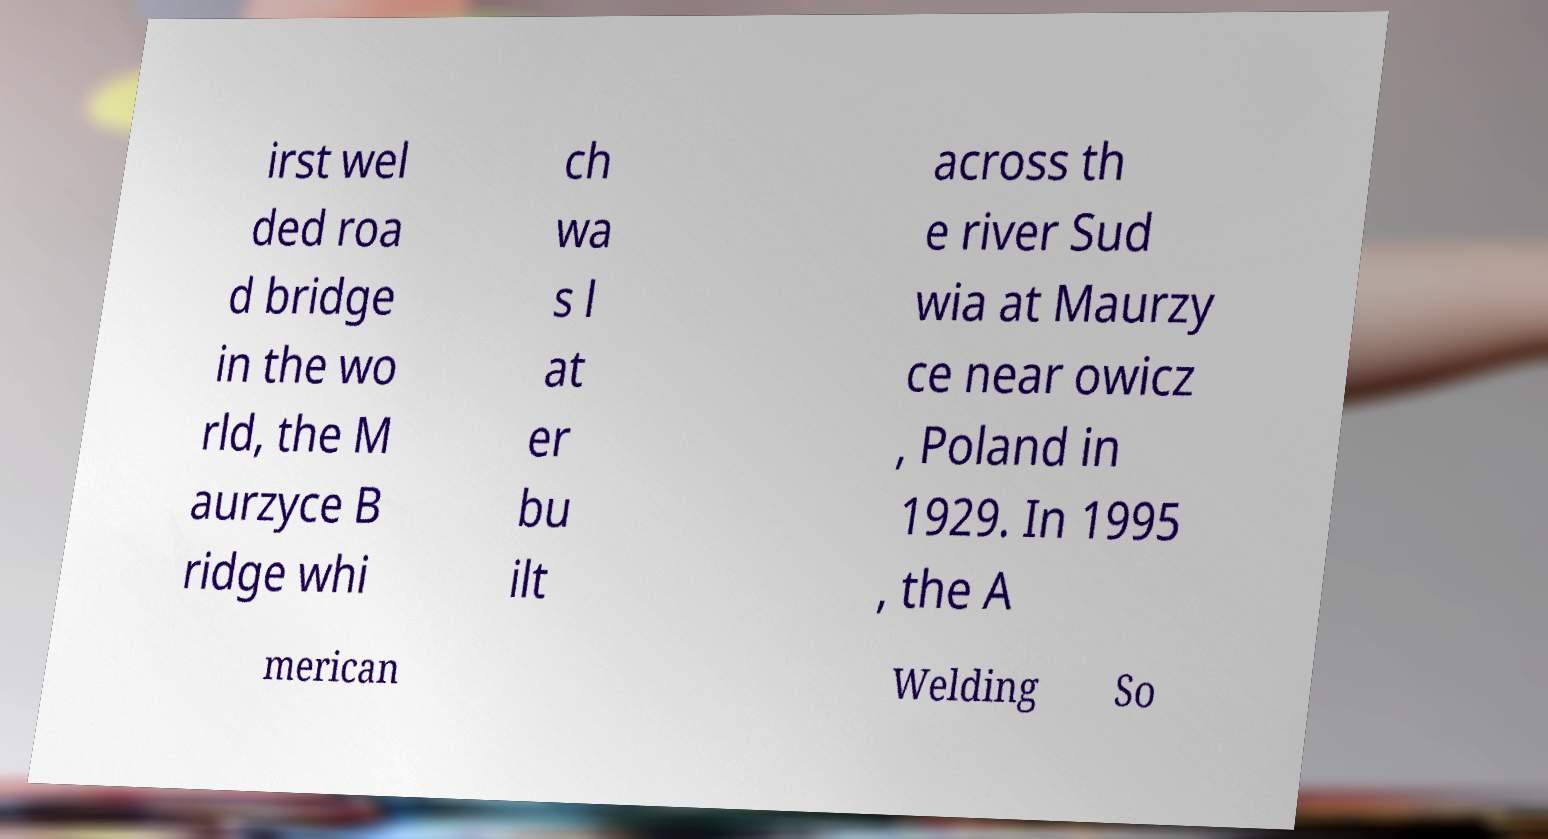Please read and relay the text visible in this image. What does it say? irst wel ded roa d bridge in the wo rld, the M aurzyce B ridge whi ch wa s l at er bu ilt across th e river Sud wia at Maurzy ce near owicz , Poland in 1929. In 1995 , the A merican Welding So 